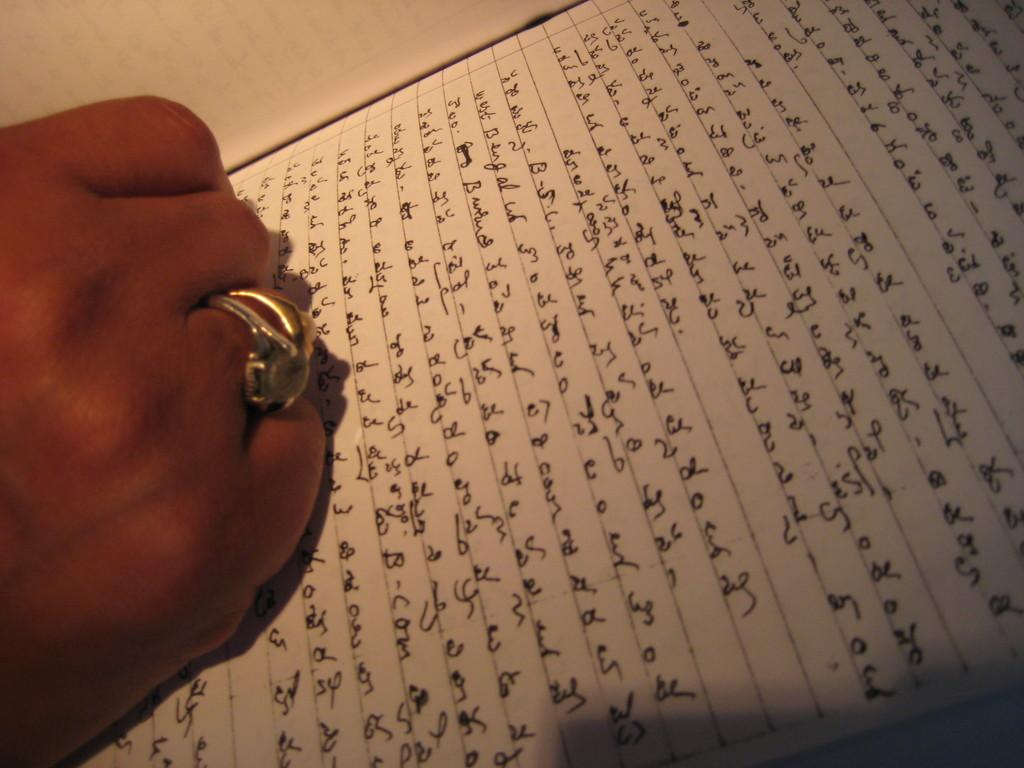What is on the paper that is visible in the image? There is a paper with writing in the image. What can be determined about the color of the ink used for the writing? The writing is in black ink. Can you describe the person in the image? There is a person in the image, and they are wearing rings on their fingers. What type of club is the person holding in the image? There is no club present in the image; the person is wearing rings on their fingers. What time of day is it in the image, considering the afternoon? The time of day is not mentioned in the image or the provided facts, so it cannot be determined from the information given. 